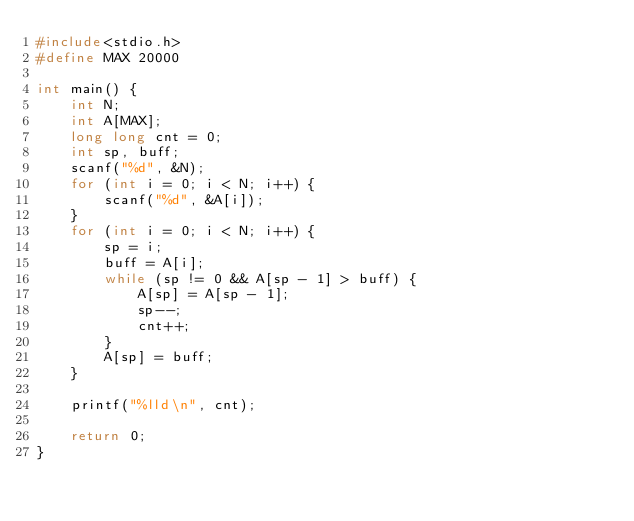Convert code to text. <code><loc_0><loc_0><loc_500><loc_500><_C_>#include<stdio.h>
#define MAX 20000

int main() {
	int N;
	int A[MAX];
	long long cnt = 0;
	int sp, buff;
	scanf("%d", &N);
	for (int i = 0; i < N; i++) {
		scanf("%d", &A[i]);
	}
	for (int i = 0; i < N; i++) {
		sp = i;
		buff = A[i];
		while (sp != 0 && A[sp - 1] > buff) {
			A[sp] = A[sp - 1];
			sp--;
			cnt++;
		}
		A[sp] = buff;
	}

	printf("%lld\n", cnt);

	return 0;
}

</code> 